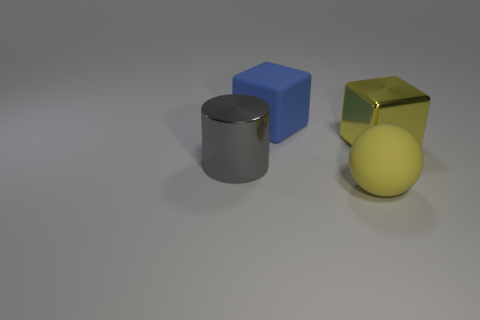What material is the ball?
Give a very brief answer. Rubber. What number of large metallic cylinders are behind the metallic cube?
Give a very brief answer. 0. Is the metallic block the same color as the large ball?
Ensure brevity in your answer.  Yes. How many spheres have the same color as the cylinder?
Your answer should be very brief. 0. Is the number of large cubes greater than the number of shiny cylinders?
Offer a very short reply. Yes. There is a object that is both left of the rubber ball and to the right of the gray metal object; what is its size?
Make the answer very short. Large. Is the material of the block that is on the left side of the large metallic cube the same as the large yellow object that is behind the big yellow rubber sphere?
Provide a succinct answer. No. There is a gray thing that is the same size as the blue rubber cube; what is its shape?
Keep it short and to the point. Cylinder. Are there fewer big yellow things than large shiny cubes?
Offer a very short reply. No. There is a big metal object that is in front of the metallic block; are there any big yellow metal things right of it?
Offer a very short reply. Yes. 